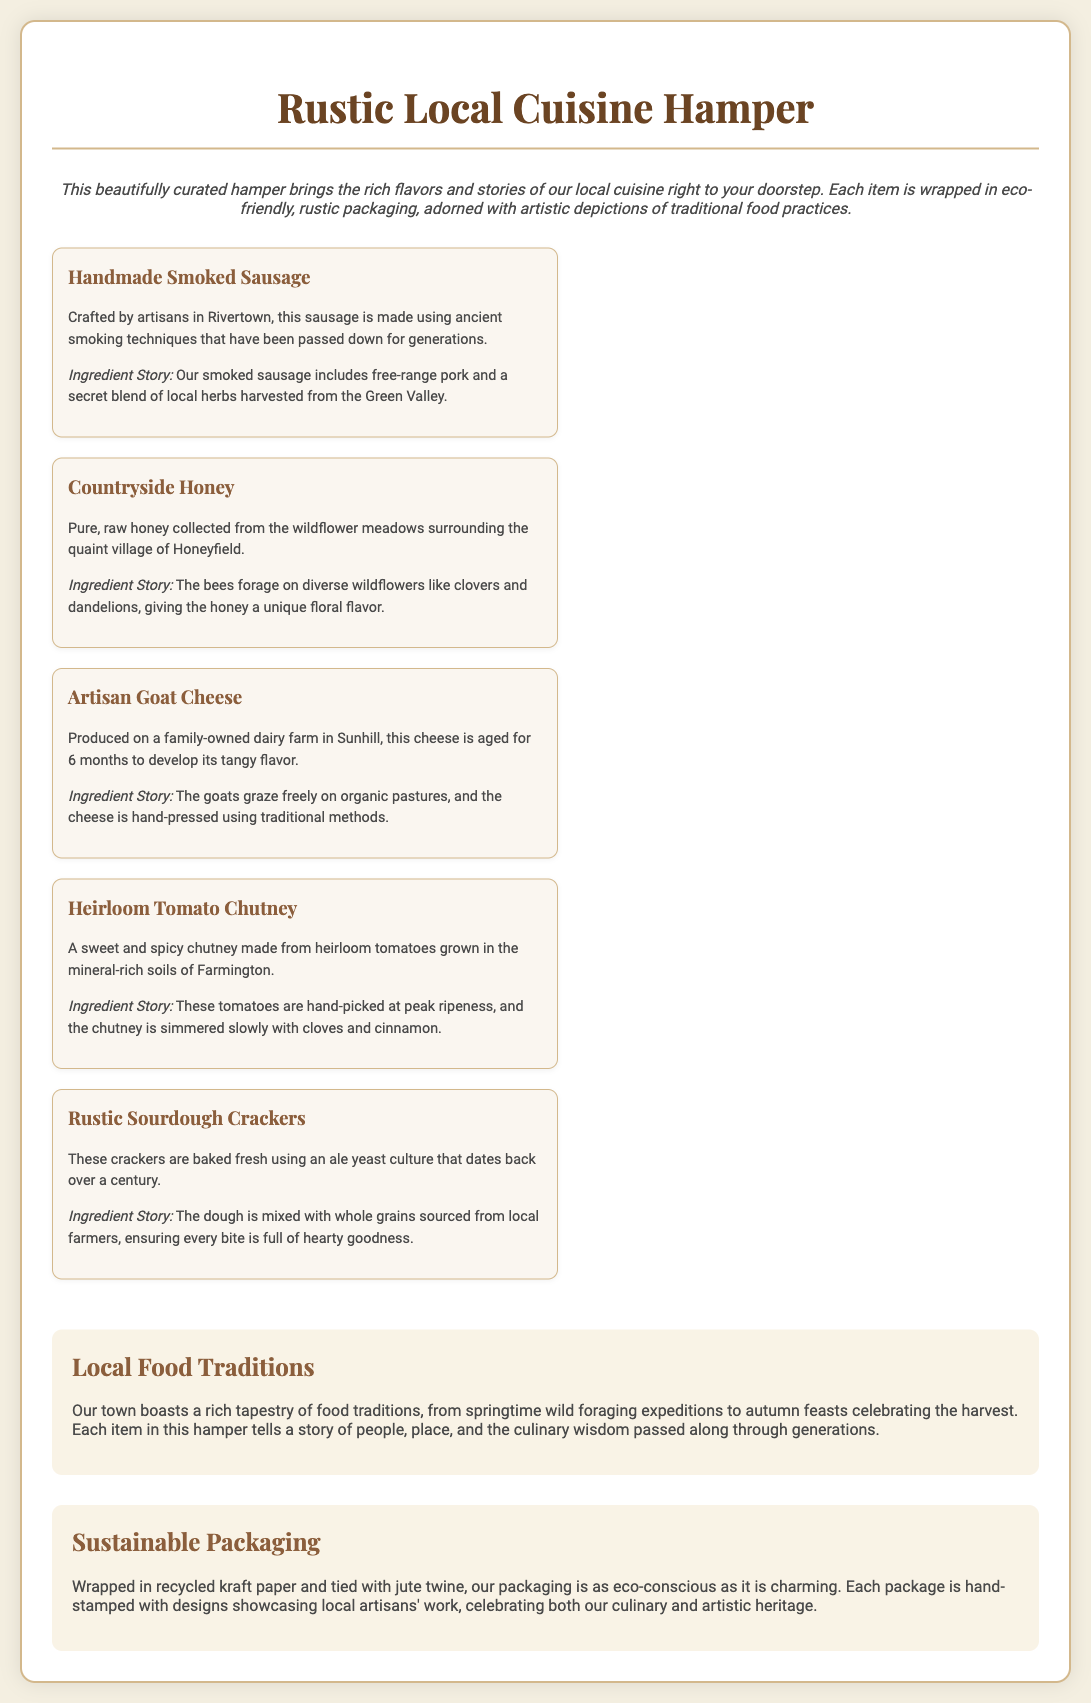What is the name of the hamper? The document prominently displays the name of the product at the top section as "Rustic Local Cuisine Hamper."
Answer: Rustic Local Cuisine Hamper What type of packaging is used? The document describes the packaging in the "Sustainable Packaging" section, stating it is made from recycled kraft paper.
Answer: recycled kraft paper Where is the handmade smoked sausage crafted? The ingredient story mentions that the sausage is crafted by artisans in Rivertown.
Answer: Rivertown How long is the artisan goat cheese aged? The text specifies that the goat cheese is aged for 6 months to develop its flavor.
Answer: 6 months What is the primary ingredient in the countryside honey? The description notes that the honey is collected from the wildflower meadows surrounding the village of Honeyfield.
Answer: wildflower meadows What traditional food practice is used in the production of the handmade smoked sausage? The ingredient story highlights that ancient smoking techniques have been passed down for generations.
Answer: ancient smoking techniques What scenic feature is celebrated in the local food traditions? The text states that local food traditions include "springtime wild foraging expeditions."
Answer: springtime wild foraging expeditions Who collects the honey described in the hamper? The document attributes the collection of honey to bees foraging on diverse wildflowers.
Answer: bees What type of twine is used to tie the packaging? The packaging description specifies that it is tied with jute twine.
Answer: jute twine 